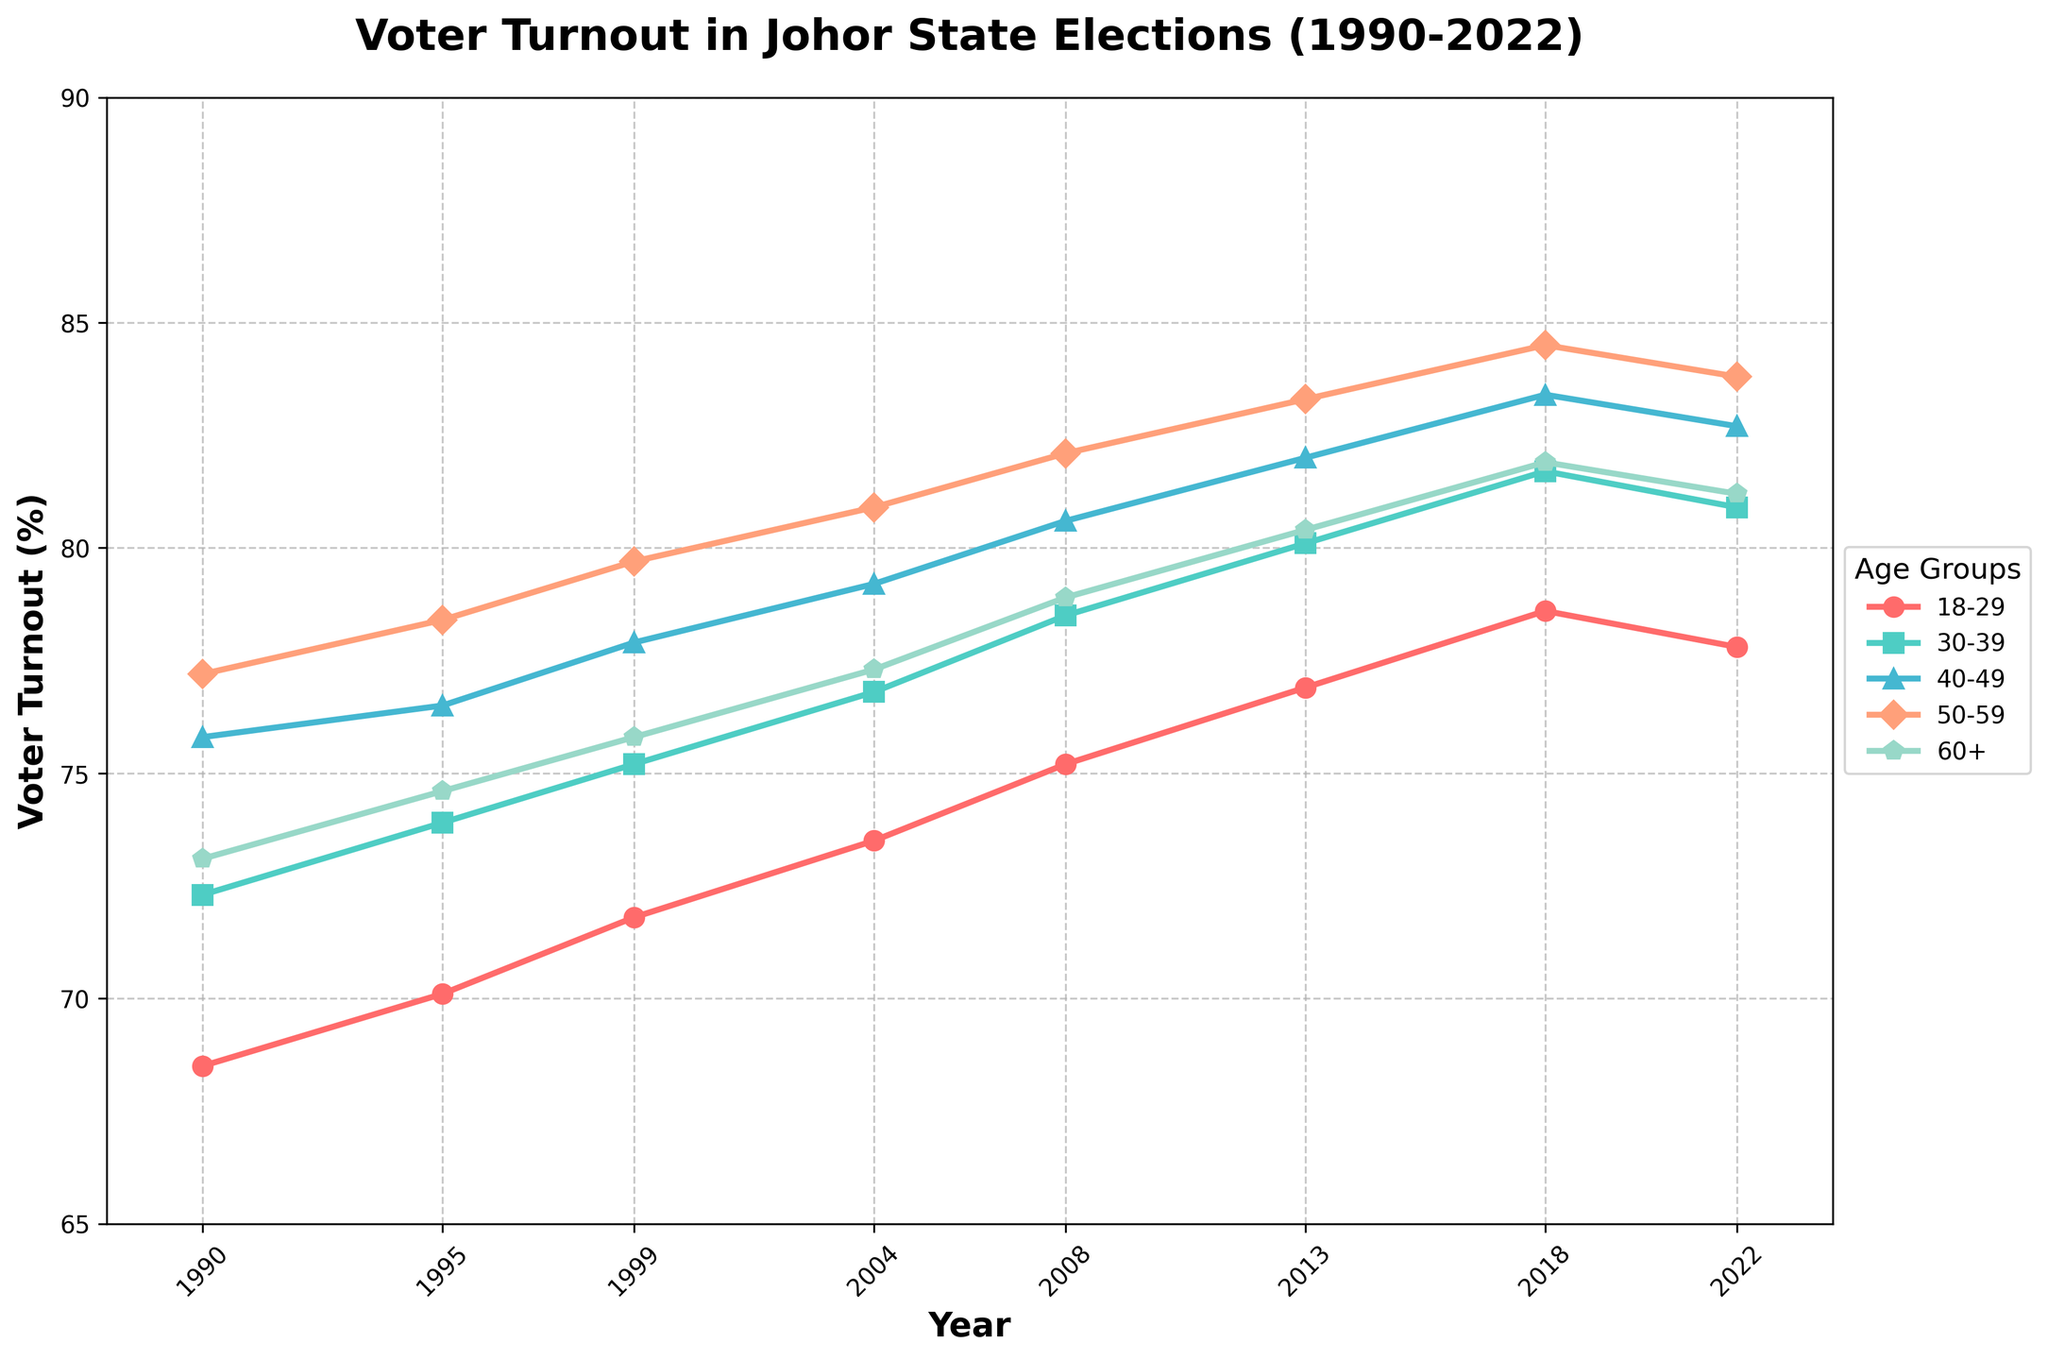What is the voter turnout percentage for the 30-39 age group in 2008? Look at the point on the line representing the 30-39 age group for the year 2008. The value is 78.5.
Answer: 78.5% Which age group had the highest voter turnout in 2022? Examine the points in 2022, and note that the 50-59 age group has the highest voter turnout at 83.8%.
Answer: 50-59 Did the voter turnout percentage for the 18-29 age group increase or decrease from 1990 to 2022? Compare the voter turnout percentage of the 18-29 age group between 1990 (68.5%) and 2022 (77.8%). There is an increase.
Answer: Increase What is the difference in voter turnout percentage between the 40-49 and 50-59 age groups in 2018? Subtract the turnout percentage of the 40-49 group (83.4%) from the 50-59 group (84.5%) in 2018. The difference is 1.1%.
Answer: 1.1% What's the average voter turnout percentage for the 60+ age group between 1990 and 2022? Calculate the average: (73.1 + 74.6 + 75.8 + 77.3 + 78.9 + 80.4 + 81.9 + 81.2) / 8 = 77.9.
Answer: 77.9% In which year did the 30-39 age group surpass the 80% voter turnout mark? Look for the year where the 30-39 age group's turnout first exceeds 80%. It's in 2013 (80.1%).
Answer: 2013 By how much did the voter turnout percentage for the 18-29 age group fluctuate between 1990 and 2018? Calculate the difference between the minimum (68.5% in 1990) and maximum (78.6% in 2018) values of the 18-29 age group. The fluctuation is 10.1%.
Answer: 10.1% What is the trend of voter turnout in the 50-59 age group from 1990 to 2022? Observe the upward trajectory in the voter turnout percentage for this age group from 77.2% in 1990 to 83.8% in 2022. It's a continuous increase.
Answer: Increasing Which two age groups have the smallest difference in voter turnout percentage in 2022? Compare the 2022 values, noting that the 50-59 and 60+ age groups have the smallest difference: 83.8% - 81.2% = 2.6%.
Answer: 50-59 and 60+ In 2004, which age group had the second highest voter turnout percentage? Identify that the 50-59 age group had the highest turnout (80.9%) and the 40-49 age group had the second highest (79.2%).
Answer: 40-49 